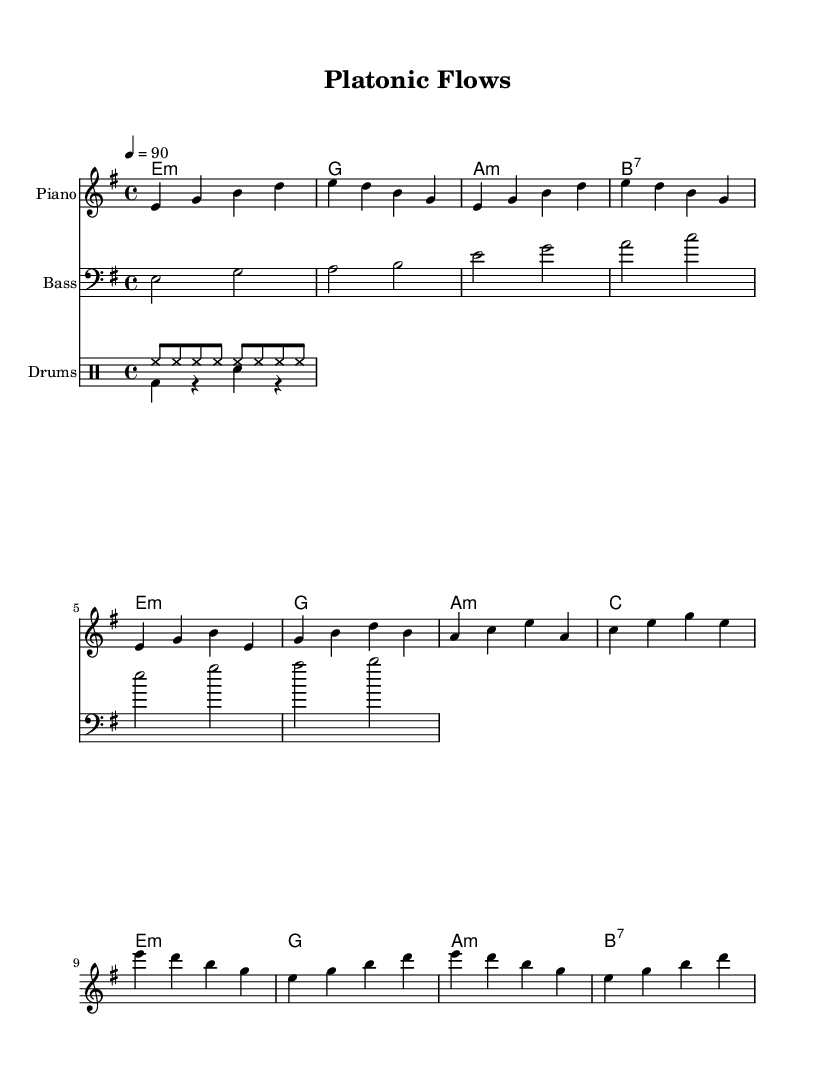What is the key signature of this music? The key signature is indicated by the absence of any sharps or flats in the music staff, along with the presence of E minor chords, which suggests that the piece is in E minor.
Answer: E minor What is the time signature of this music? The time signature is found at the beginning of the piece and indicates how many beats are in each measure. Here, the '4/4' time signature shows that there are four beats per measure, with the quarter note receiving one beat.
Answer: 4/4 What is the tempo marking of the piece? The tempo is specified in the score, stating that the piece should be played at a speed of 90 beats per minute. This is indicated within the score and provides a clear metric for performance.
Answer: 90 How many measures are in the verse section of the piece? The verse section is determined by counting the measures within the specified verse melody lines in the sheet music. There are four measures marked in the verse part.
Answer: 4 What type of harmony is predominantly used in the chorus? The chord progression in the chorus is established through the analysis of the chord symbols appearing alongside the melody. The combination of minor and dominant 7th chords creates a smooth harmonic flow in the chorus.
Answer: Minor and dominant 7th What kind of drum pattern is used in the verse section? The verse features a specific drum pattern that is outlined in the drum section of the sheet music. Analyzing the notation reveals the use of a bass drum and snare in a syncopated rhythm, typical of hip hop beats.
Answer: Syncopated How does the lyrical content relate to the ancient philosophy explored in the theme? While the sheet music does not provide explicit lyrics, the title and thematic elements suggest that the construction of melodies and the flow of rhythms are reflective of deeper philosophical concepts, which connect to the ideals and teachings of ancient philosophers.
Answer: Deep philosophical connections 